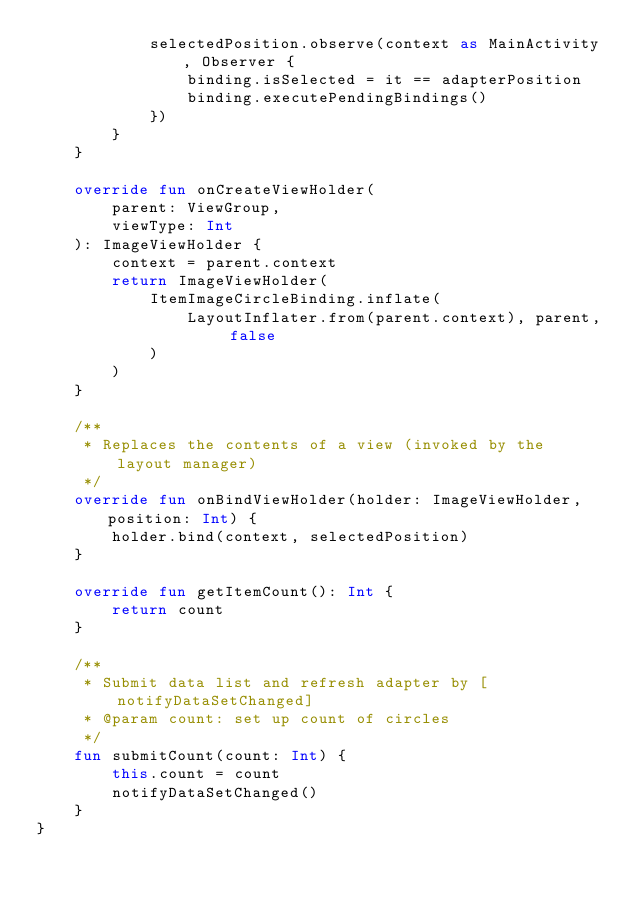<code> <loc_0><loc_0><loc_500><loc_500><_Kotlin_>            selectedPosition.observe(context as MainActivity, Observer {
                binding.isSelected = it == adapterPosition
                binding.executePendingBindings()
            })
        }
    }

    override fun onCreateViewHolder(
        parent: ViewGroup,
        viewType: Int
    ): ImageViewHolder {
        context = parent.context
        return ImageViewHolder(
            ItemImageCircleBinding.inflate(
                LayoutInflater.from(parent.context), parent, false
            )
        )
    }

    /**
     * Replaces the contents of a view (invoked by the layout manager)
     */
    override fun onBindViewHolder(holder: ImageViewHolder, position: Int) {
        holder.bind(context, selectedPosition)
    }

    override fun getItemCount(): Int {
        return count
    }

    /**
     * Submit data list and refresh adapter by [notifyDataSetChanged]
     * @param count: set up count of circles
     */
    fun submitCount(count: Int) {
        this.count = count
        notifyDataSetChanged()
    }
}</code> 